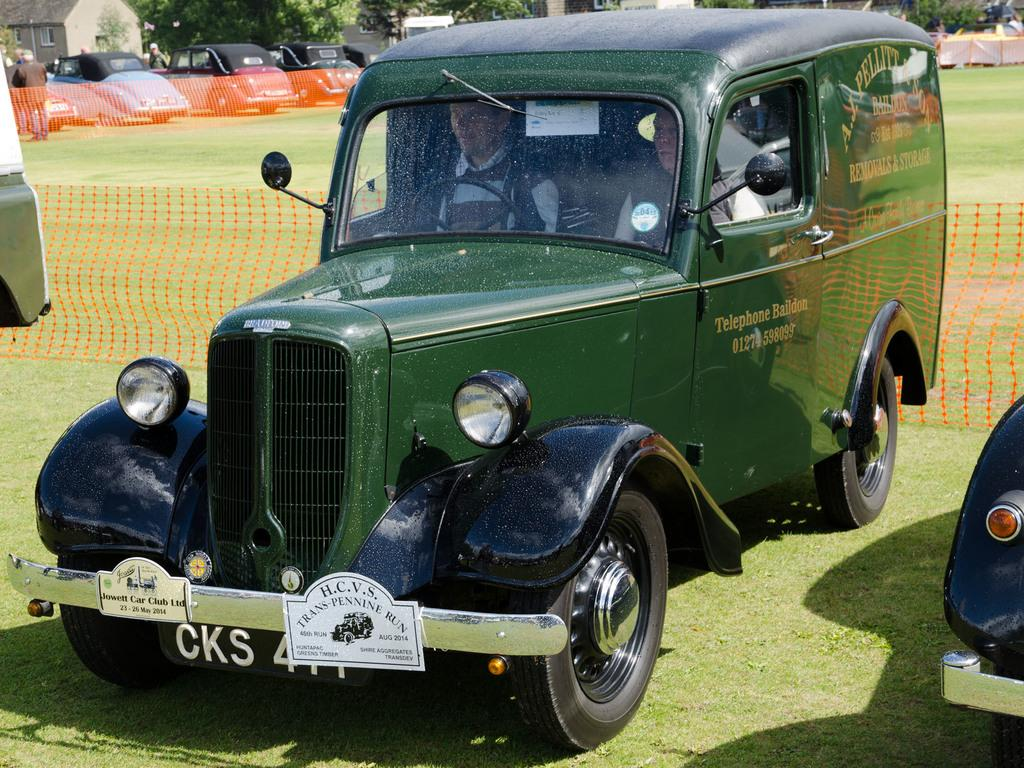What type of objects are on the ground in the image? There are motor vehicles on the ground in the image. What can be seen in the distance behind the motor vehicles? There are buildings and trees in the background of the image. How many legs can be seen on the motor vehicles in the image? Motor vehicles do not have legs; they have wheels. 